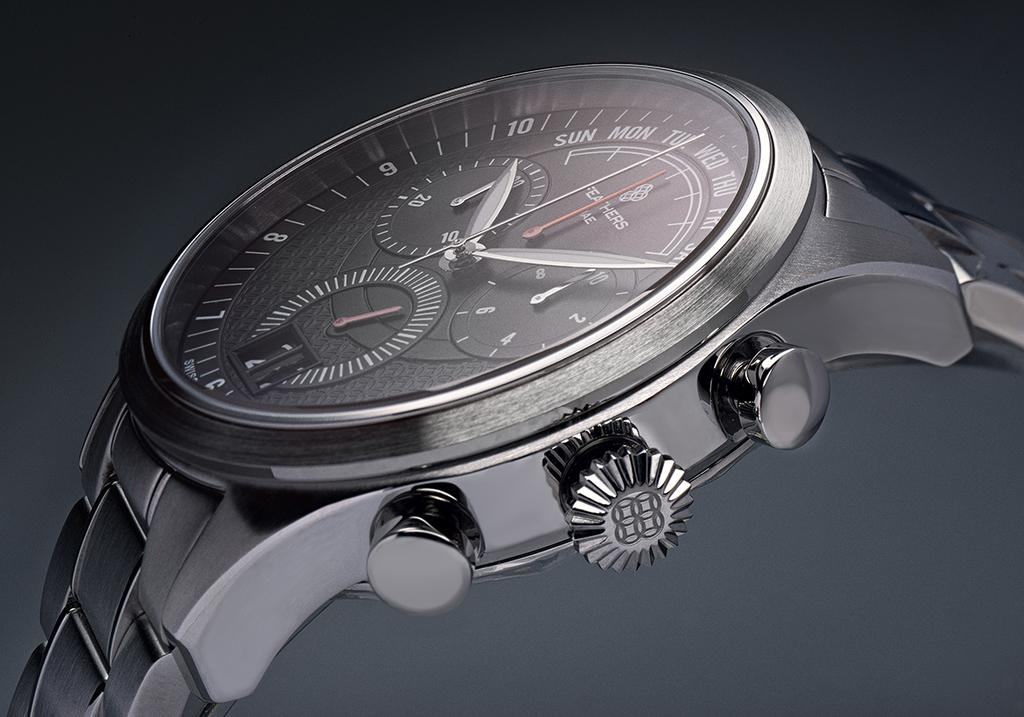<image>
Render a clear and concise summary of the photo. A wristwatch that indicates the time as 10:10. 